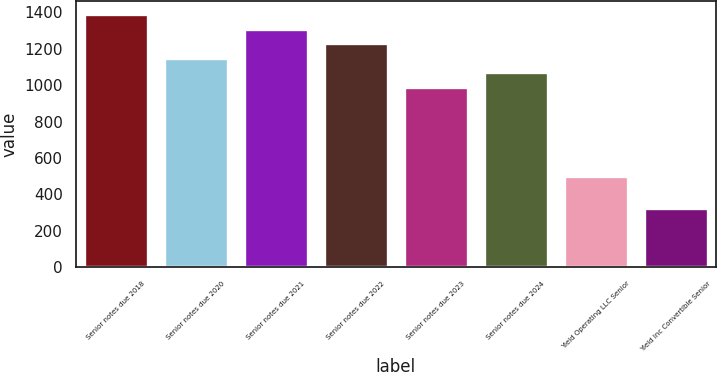<chart> <loc_0><loc_0><loc_500><loc_500><bar_chart><fcel>Senior notes due 2018<fcel>Senior notes due 2020<fcel>Senior notes due 2021<fcel>Senior notes due 2022<fcel>Senior notes due 2023<fcel>Senior notes due 2024<fcel>Yield Operating LLC Senior<fcel>Yield Inc Convertible Senior<nl><fcel>1392<fcel>1150.8<fcel>1311.6<fcel>1231.2<fcel>990<fcel>1070.4<fcel>500<fcel>326<nl></chart> 